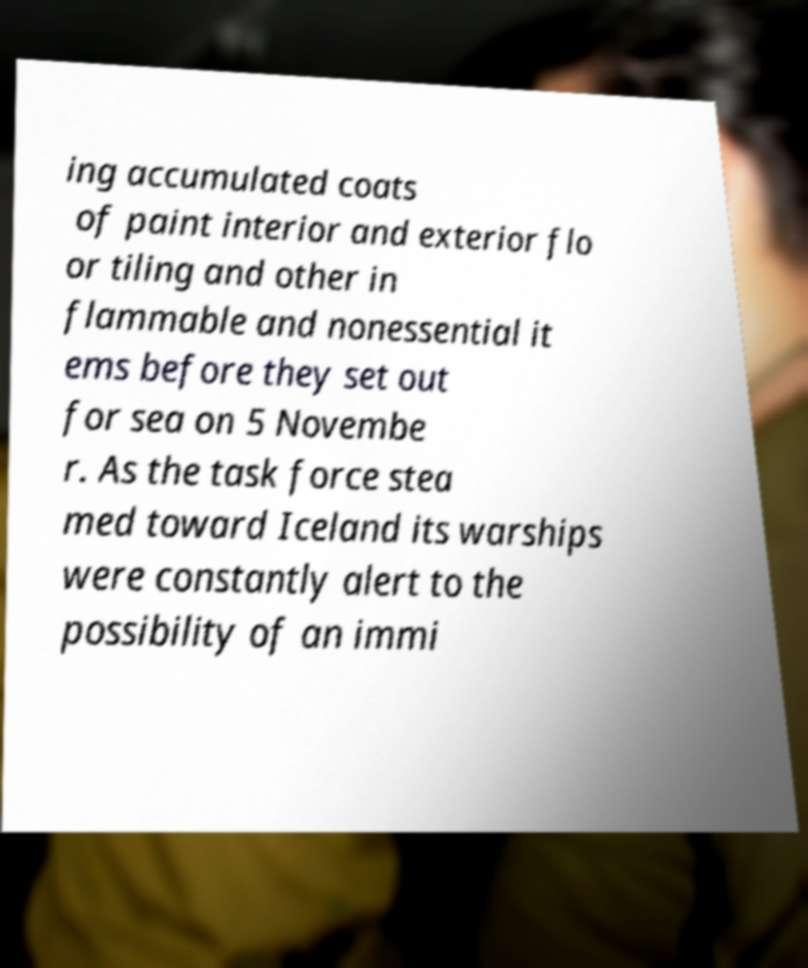There's text embedded in this image that I need extracted. Can you transcribe it verbatim? ing accumulated coats of paint interior and exterior flo or tiling and other in flammable and nonessential it ems before they set out for sea on 5 Novembe r. As the task force stea med toward Iceland its warships were constantly alert to the possibility of an immi 